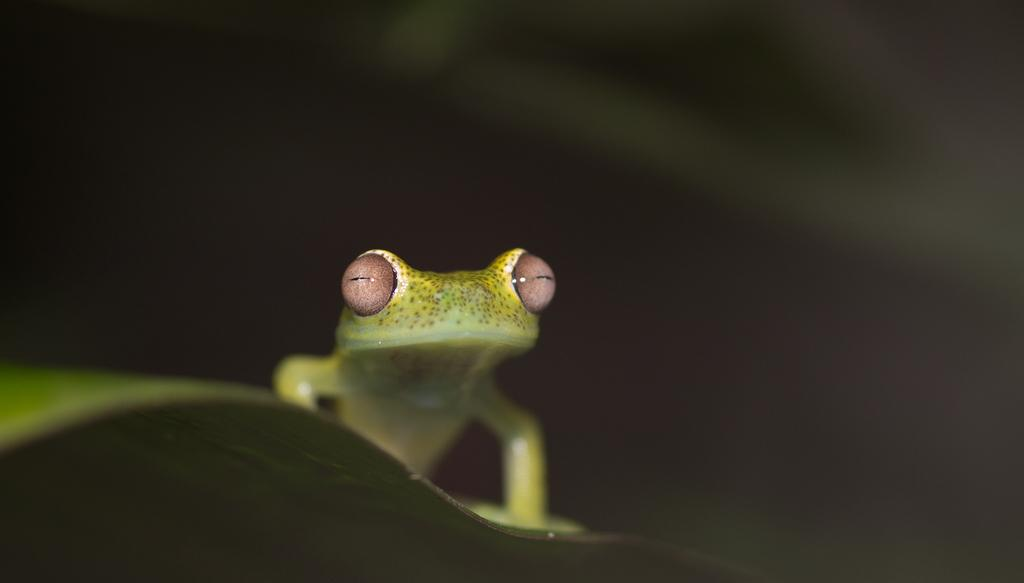What animal is present in the image? There is a frog in the image. Where is the frog located? The frog is on a leaf. Can you describe the background of the image? The background of the image is blurry. What level of difficulty does the frog have in completing the beginner's course in the image? There is no indication of a course or level of difficulty in the image, as it only features a frog on a leaf with a blurry background. 